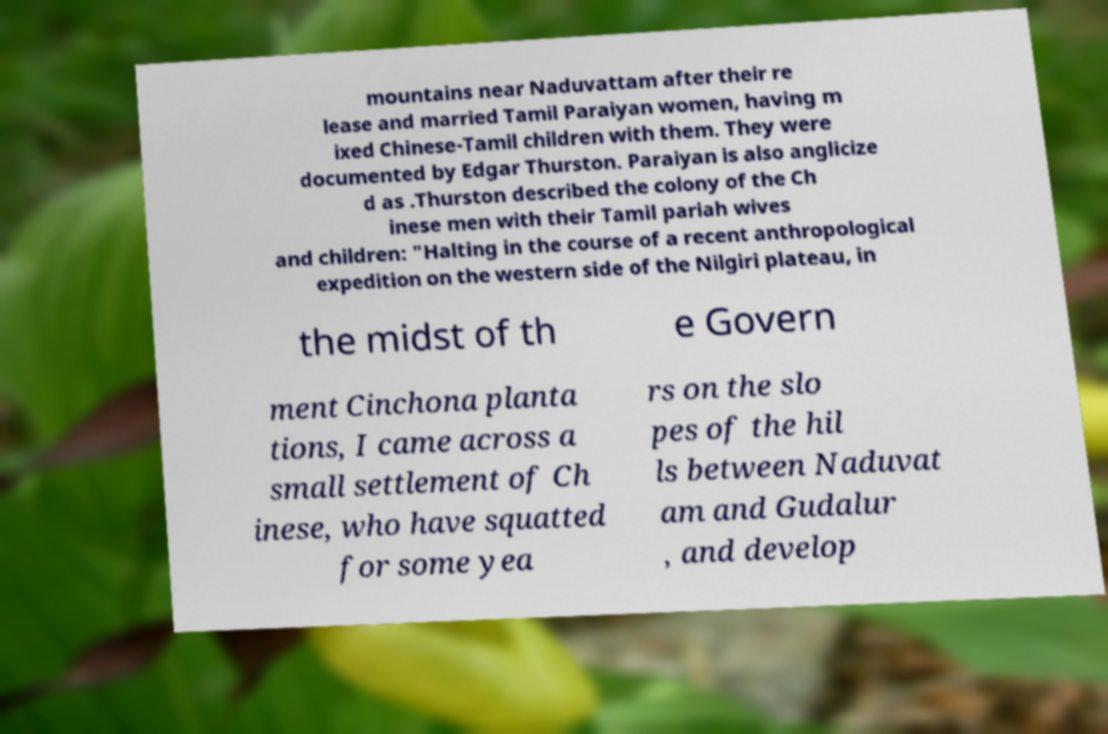Can you accurately transcribe the text from the provided image for me? mountains near Naduvattam after their re lease and married Tamil Paraiyan women, having m ixed Chinese-Tamil children with them. They were documented by Edgar Thurston. Paraiyan is also anglicize d as .Thurston described the colony of the Ch inese men with their Tamil pariah wives and children: "Halting in the course of a recent anthropological expedition on the western side of the Nilgiri plateau, in the midst of th e Govern ment Cinchona planta tions, I came across a small settlement of Ch inese, who have squatted for some yea rs on the slo pes of the hil ls between Naduvat am and Gudalur , and develop 